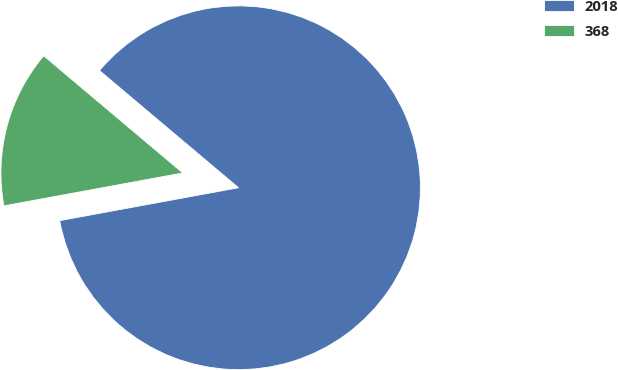Convert chart to OTSL. <chart><loc_0><loc_0><loc_500><loc_500><pie_chart><fcel>2018<fcel>368<nl><fcel>85.96%<fcel>14.04%<nl></chart> 